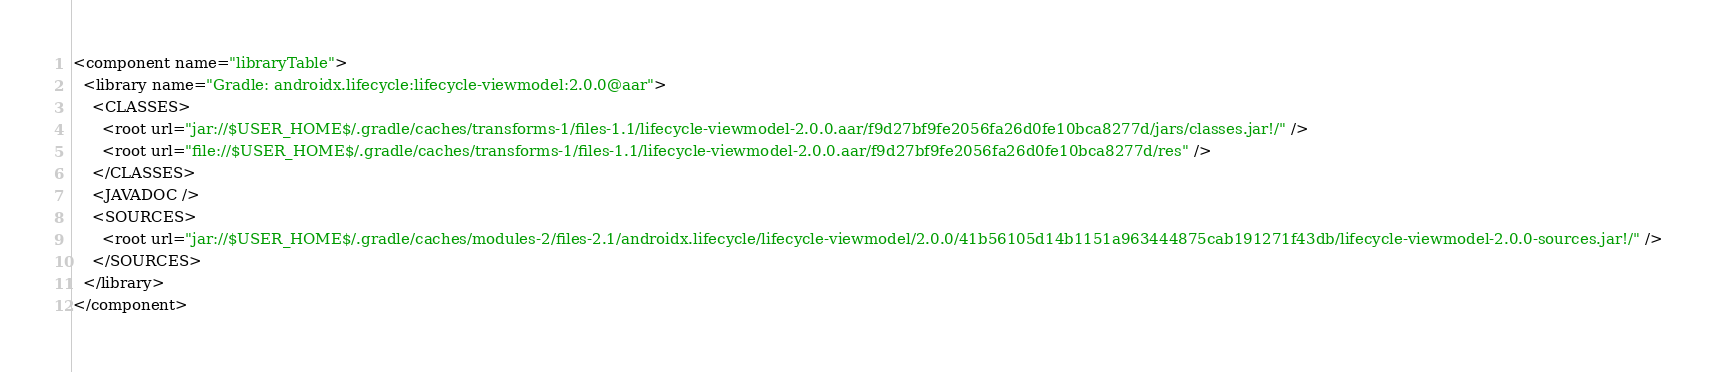Convert code to text. <code><loc_0><loc_0><loc_500><loc_500><_XML_><component name="libraryTable">
  <library name="Gradle: androidx.lifecycle:lifecycle-viewmodel:2.0.0@aar">
    <CLASSES>
      <root url="jar://$USER_HOME$/.gradle/caches/transforms-1/files-1.1/lifecycle-viewmodel-2.0.0.aar/f9d27bf9fe2056fa26d0fe10bca8277d/jars/classes.jar!/" />
      <root url="file://$USER_HOME$/.gradle/caches/transforms-1/files-1.1/lifecycle-viewmodel-2.0.0.aar/f9d27bf9fe2056fa26d0fe10bca8277d/res" />
    </CLASSES>
    <JAVADOC />
    <SOURCES>
      <root url="jar://$USER_HOME$/.gradle/caches/modules-2/files-2.1/androidx.lifecycle/lifecycle-viewmodel/2.0.0/41b56105d14b1151a963444875cab191271f43db/lifecycle-viewmodel-2.0.0-sources.jar!/" />
    </SOURCES>
  </library>
</component></code> 